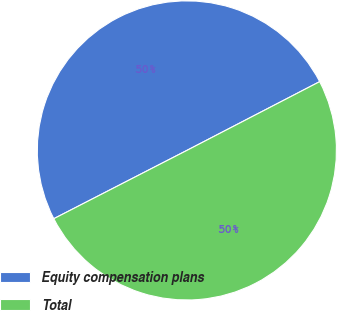Convert chart to OTSL. <chart><loc_0><loc_0><loc_500><loc_500><pie_chart><fcel>Equity compensation plans<fcel>Total<nl><fcel>49.94%<fcel>50.06%<nl></chart> 